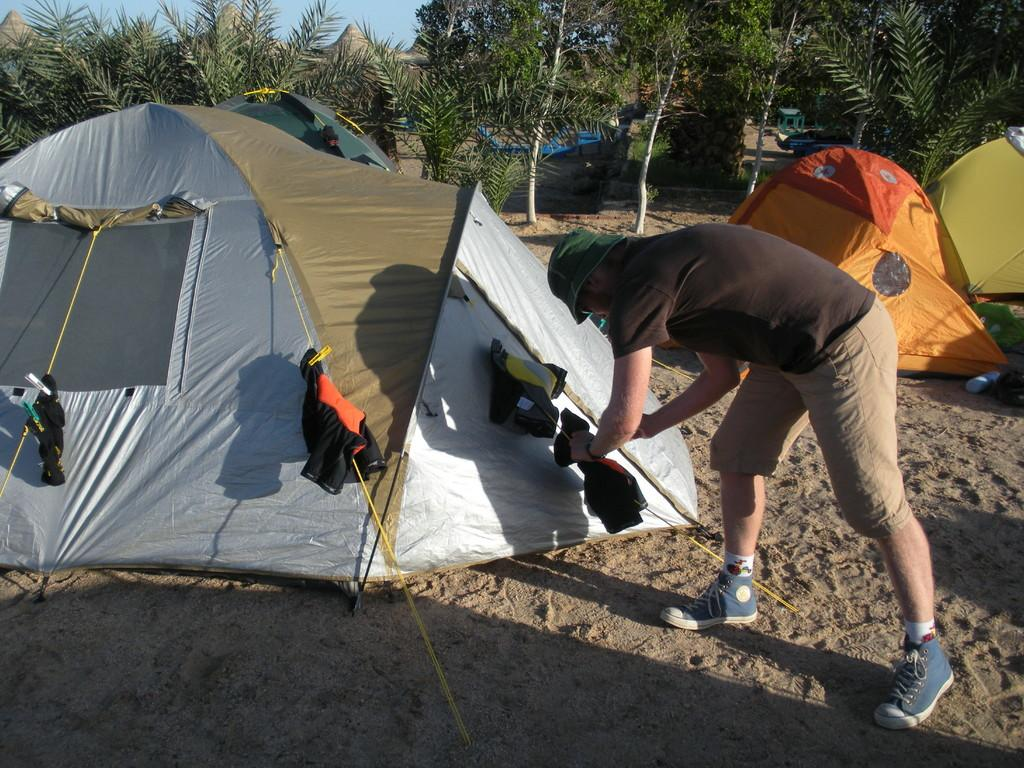What type of setting is depicted in the image? The image shows camps. What activity is being performed with the clothes in the image? Clothes are hanging on ropes in the image. What is the person in the image doing? The person is placing a cloth on a rope. What can be seen in the background of the image? There are trees and the sky visible in the background of the image. Where is the library located in the image? There is no library present in the image. How many snails can be seen crawling on the clothes in the image? There are no snails visible in the image; only clothes hanging on ropes and a person placing a cloth on a rope are present. 